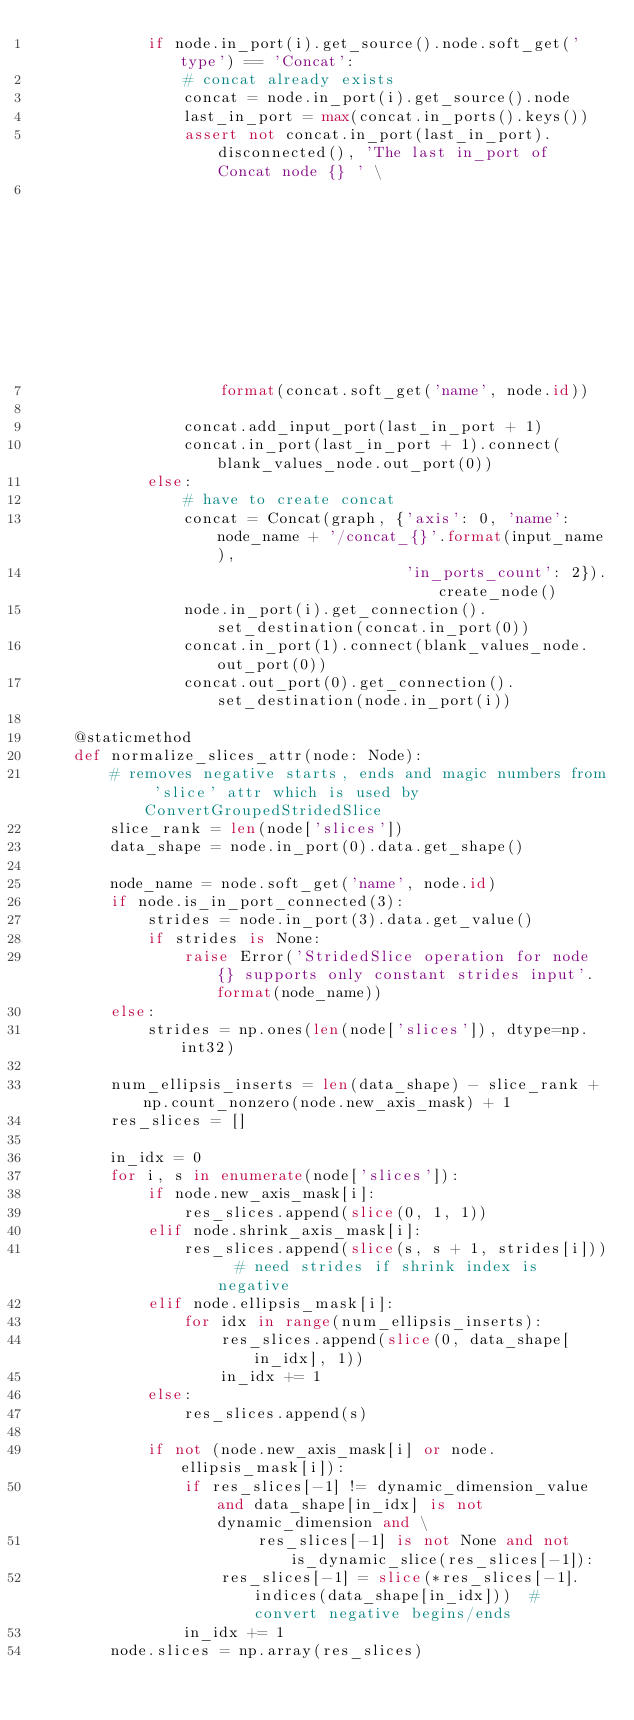<code> <loc_0><loc_0><loc_500><loc_500><_Python_>            if node.in_port(i).get_source().node.soft_get('type') == 'Concat':
                # concat already exists
                concat = node.in_port(i).get_source().node
                last_in_port = max(concat.in_ports().keys())
                assert not concat.in_port(last_in_port).disconnected(), 'The last in_port of Concat node {} ' \
                                                                        'should be connected'. \
                    format(concat.soft_get('name', node.id))

                concat.add_input_port(last_in_port + 1)
                concat.in_port(last_in_port + 1).connect(blank_values_node.out_port(0))
            else:
                # have to create concat
                concat = Concat(graph, {'axis': 0, 'name': node_name + '/concat_{}'.format(input_name),
                                        'in_ports_count': 2}).create_node()
                node.in_port(i).get_connection().set_destination(concat.in_port(0))
                concat.in_port(1).connect(blank_values_node.out_port(0))
                concat.out_port(0).get_connection().set_destination(node.in_port(i))

    @staticmethod
    def normalize_slices_attr(node: Node):
        # removes negative starts, ends and magic numbers from 'slice' attr which is used by ConvertGroupedStridedSlice
        slice_rank = len(node['slices'])
        data_shape = node.in_port(0).data.get_shape()

        node_name = node.soft_get('name', node.id)
        if node.is_in_port_connected(3):
            strides = node.in_port(3).data.get_value()
            if strides is None:
                raise Error('StridedSlice operation for node {} supports only constant strides input'.format(node_name))
        else:
            strides = np.ones(len(node['slices']), dtype=np.int32)

        num_ellipsis_inserts = len(data_shape) - slice_rank + np.count_nonzero(node.new_axis_mask) + 1
        res_slices = []

        in_idx = 0
        for i, s in enumerate(node['slices']):
            if node.new_axis_mask[i]:
                res_slices.append(slice(0, 1, 1))
            elif node.shrink_axis_mask[i]:
                res_slices.append(slice(s, s + 1, strides[i]))  # need strides if shrink index is negative
            elif node.ellipsis_mask[i]:
                for idx in range(num_ellipsis_inserts):
                    res_slices.append(slice(0, data_shape[in_idx], 1))
                    in_idx += 1
            else:
                res_slices.append(s)

            if not (node.new_axis_mask[i] or node.ellipsis_mask[i]):
                if res_slices[-1] != dynamic_dimension_value and data_shape[in_idx] is not dynamic_dimension and \
                        res_slices[-1] is not None and not is_dynamic_slice(res_slices[-1]):
                    res_slices[-1] = slice(*res_slices[-1].indices(data_shape[in_idx]))  # convert negative begins/ends
                in_idx += 1
        node.slices = np.array(res_slices)
</code> 